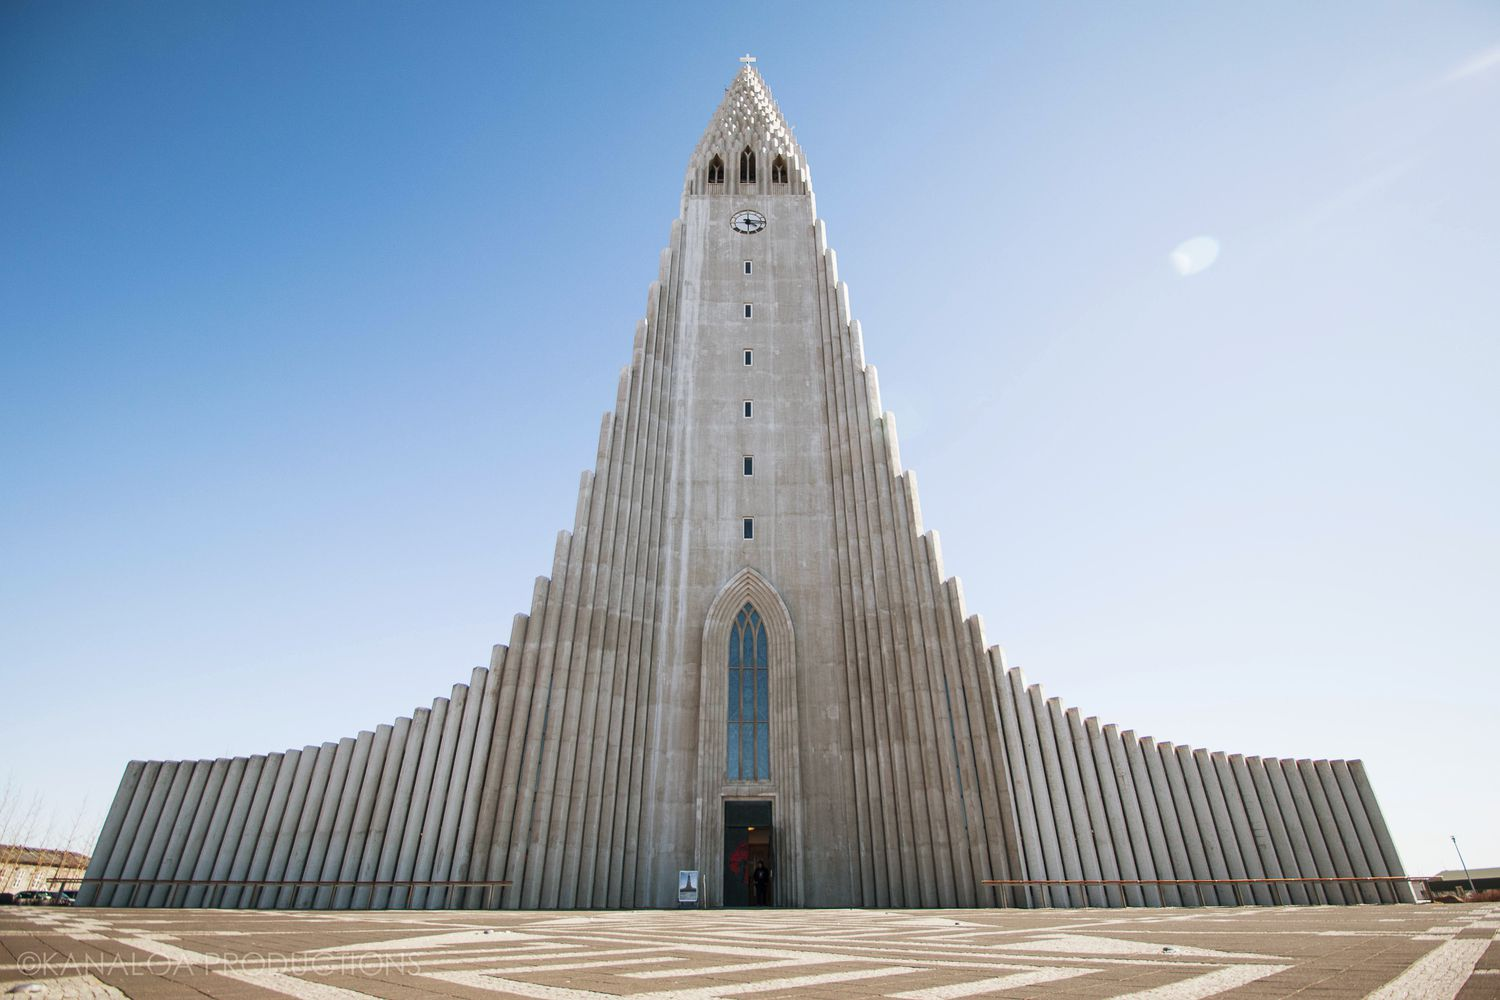What is this photo about? The image captures the grandeur of Hallgrímskirkja, an iconic Lutheran parish church located in Reykjavík, Iceland. This architectural marvel towers against a backdrop of a pristine blue sky, its imposing structure designed to resemble the basalt lava flows that are common in Iceland's landscape. The church is noted for its stark gray exterior, which contrasts sharply with the vibrant sky. The photo is taken from a low angle, emphasizing the height and striking vertical lines that lead up to its spire, topped with a small cross. The entrance is marked by a set of doors with a red hue, adding a pop of color to the otherwise monochromatic scene and conveying a sense of welcome and sanctity. The image evokes feelings of awe and tranquility, underscoring the church's status as both a place of worship and a landmark of national pride. 